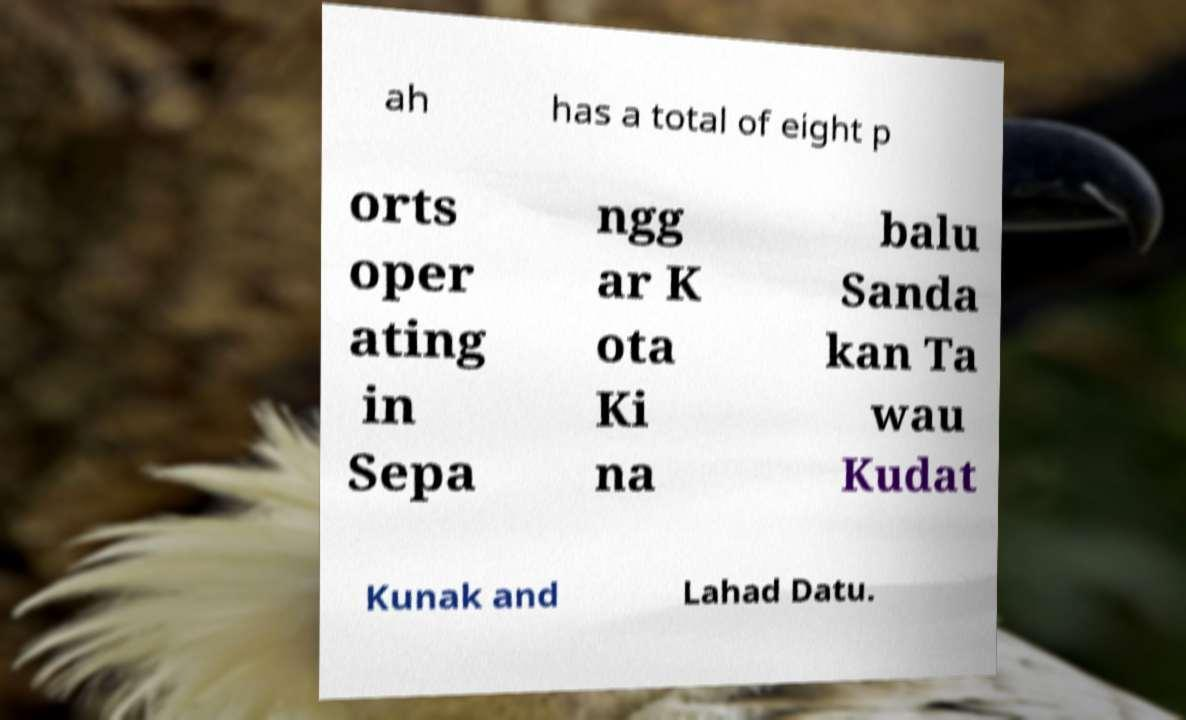Can you read and provide the text displayed in the image?This photo seems to have some interesting text. Can you extract and type it out for me? ah has a total of eight p orts oper ating in Sepa ngg ar K ota Ki na balu Sanda kan Ta wau Kudat Kunak and Lahad Datu. 